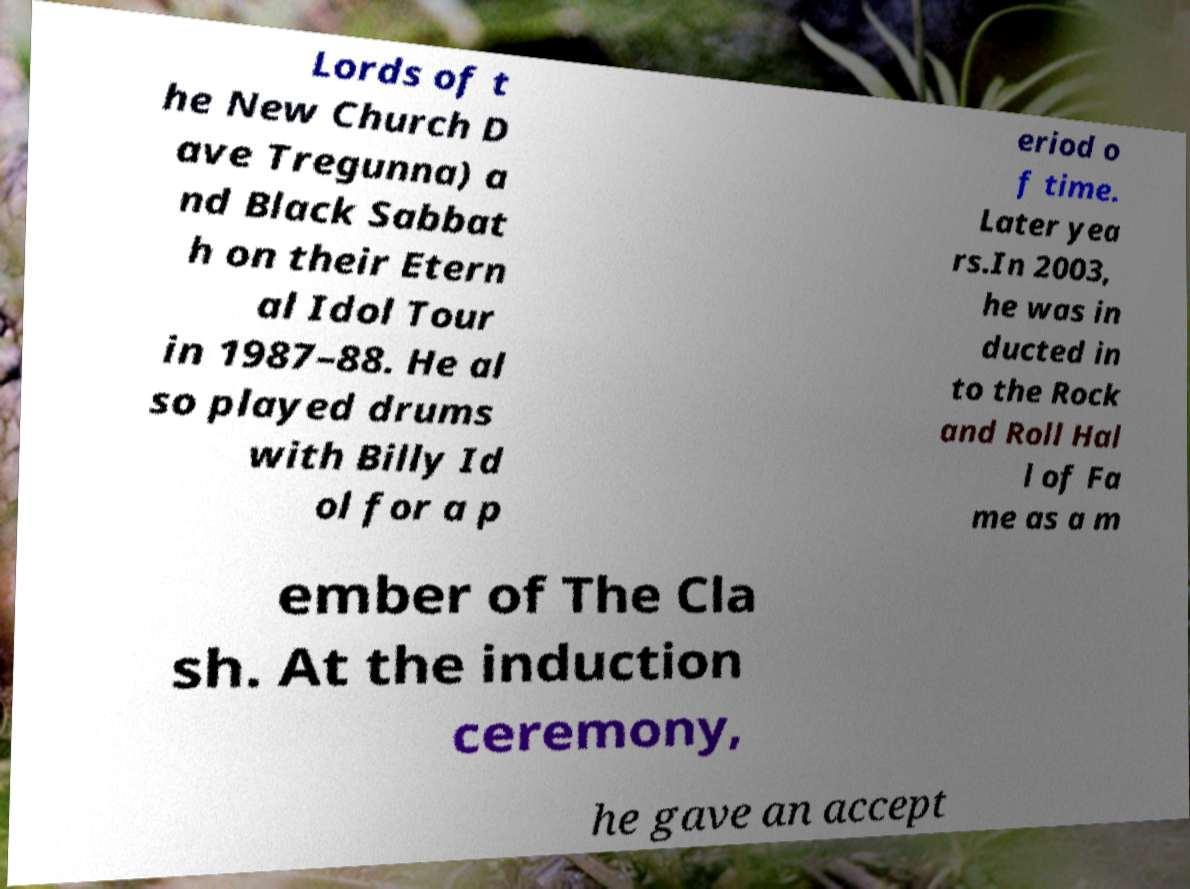There's text embedded in this image that I need extracted. Can you transcribe it verbatim? Lords of t he New Church D ave Tregunna) a nd Black Sabbat h on their Etern al Idol Tour in 1987–88. He al so played drums with Billy Id ol for a p eriod o f time. Later yea rs.In 2003, he was in ducted in to the Rock and Roll Hal l of Fa me as a m ember of The Cla sh. At the induction ceremony, he gave an accept 